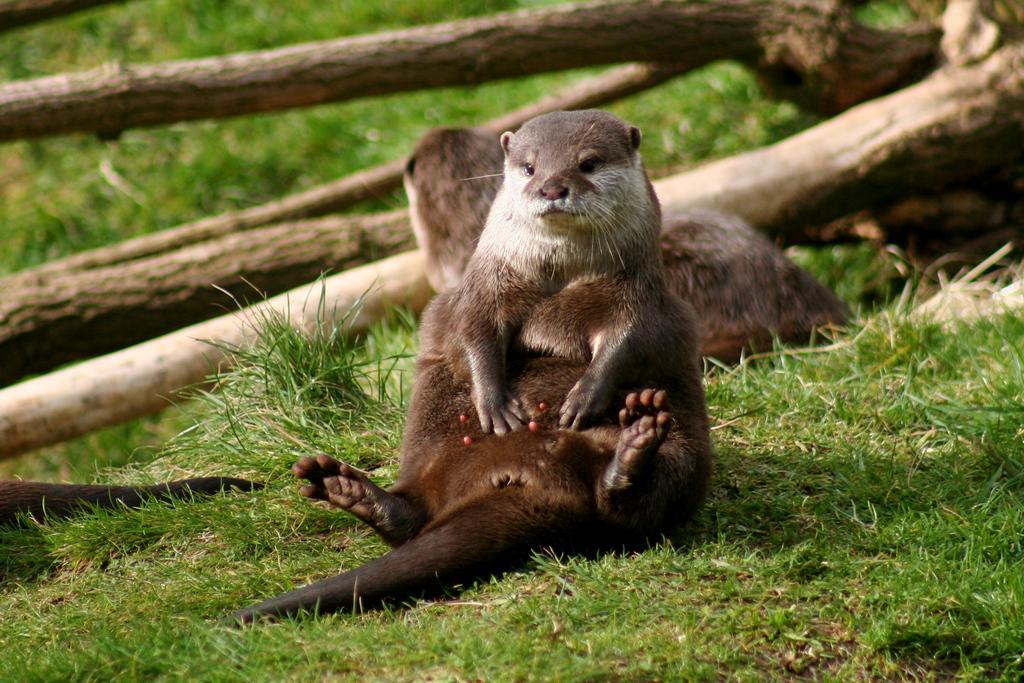Describe this image in one or two sentences. In this image we can see otters laying on the grass. In the background there are logs. 